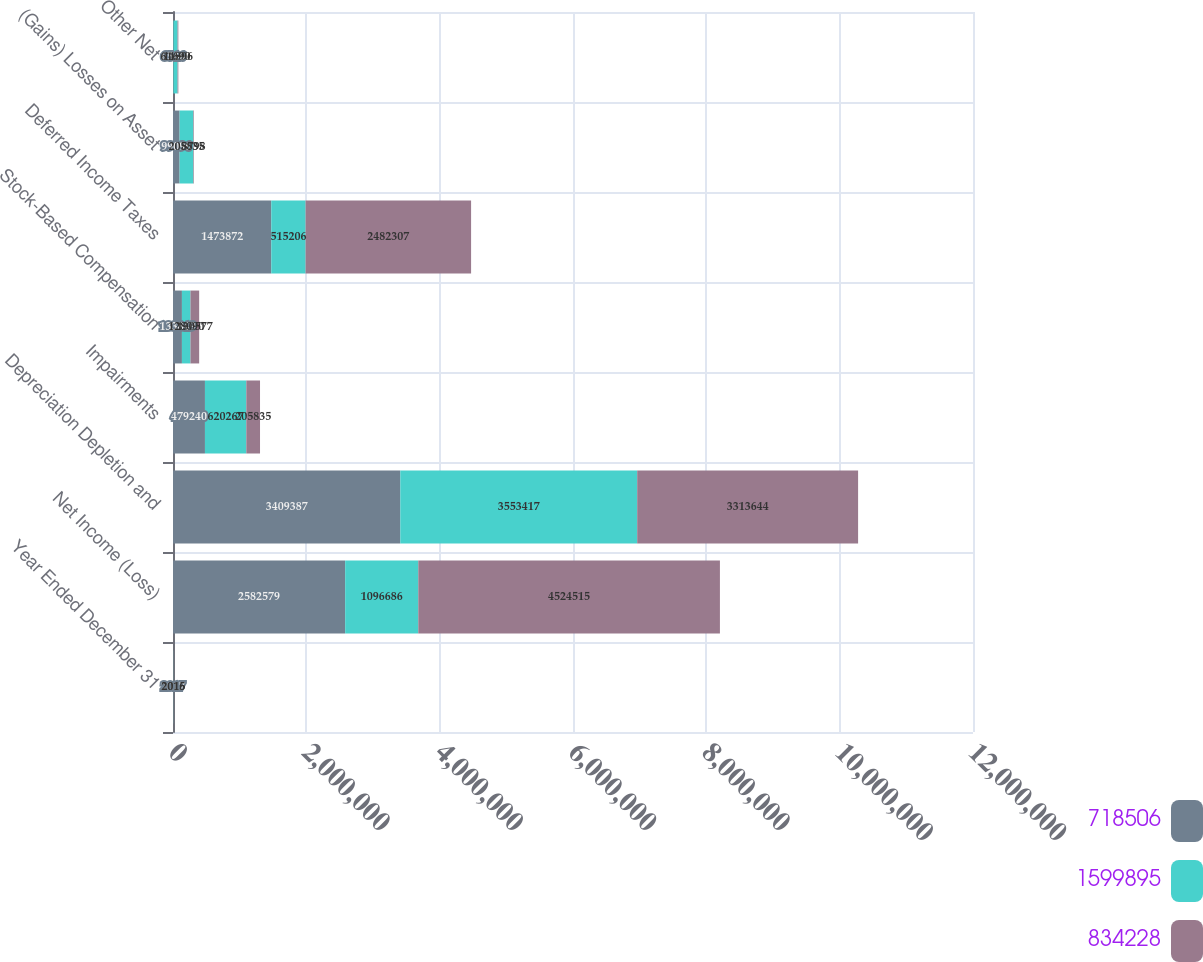<chart> <loc_0><loc_0><loc_500><loc_500><stacked_bar_chart><ecel><fcel>Year Ended December 31<fcel>Net Income (Loss)<fcel>Depreciation Depletion and<fcel>Impairments<fcel>Stock-Based Compensation<fcel>Deferred Income Taxes<fcel>(Gains) Losses on Asset<fcel>Other Net<nl><fcel>718506<fcel>2017<fcel>2.58258e+06<fcel>3.40939e+06<fcel>479240<fcel>133849<fcel>1.47387e+06<fcel>99096<fcel>6546<nl><fcel>1.5999e+06<fcel>2016<fcel>1.09669e+06<fcel>3.55342e+06<fcel>620267<fcel>128090<fcel>515206<fcel>205835<fcel>61690<nl><fcel>834228<fcel>2015<fcel>4.52452e+06<fcel>3.31364e+06<fcel>205835<fcel>130577<fcel>2.48231e+06<fcel>8798<fcel>11896<nl></chart> 